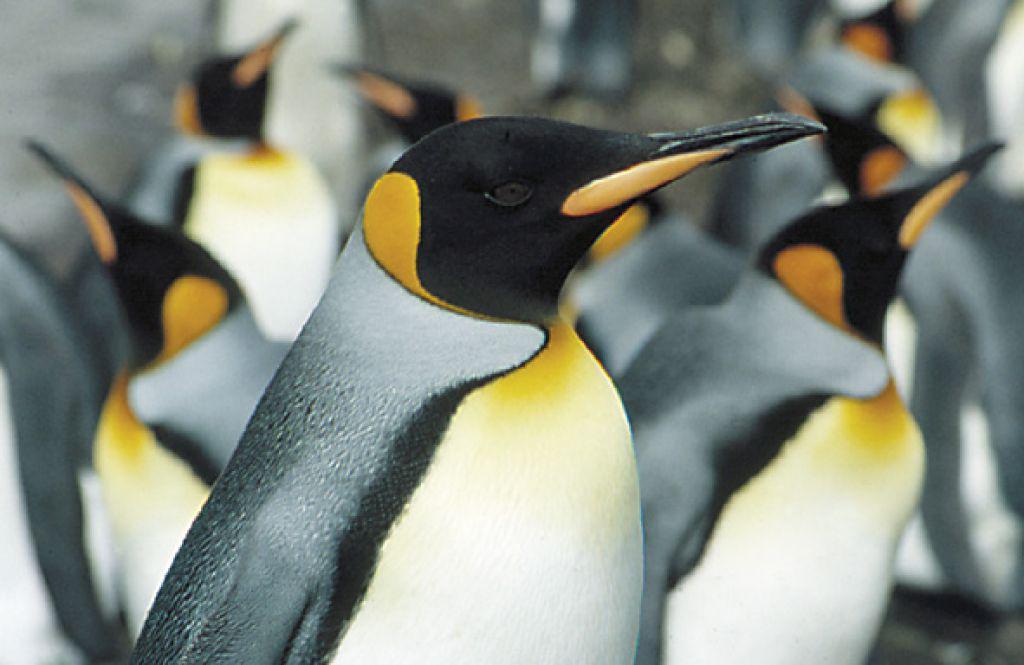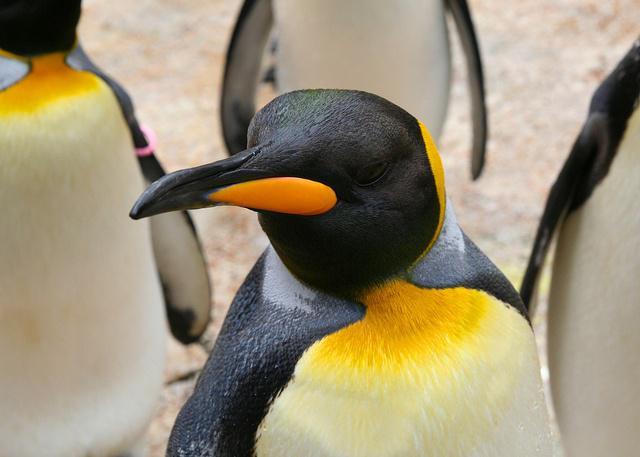The first image is the image on the left, the second image is the image on the right. Considering the images on both sides, is "There are two penguins with crossed beaks in at least one of the images." valid? Answer yes or no. No. 